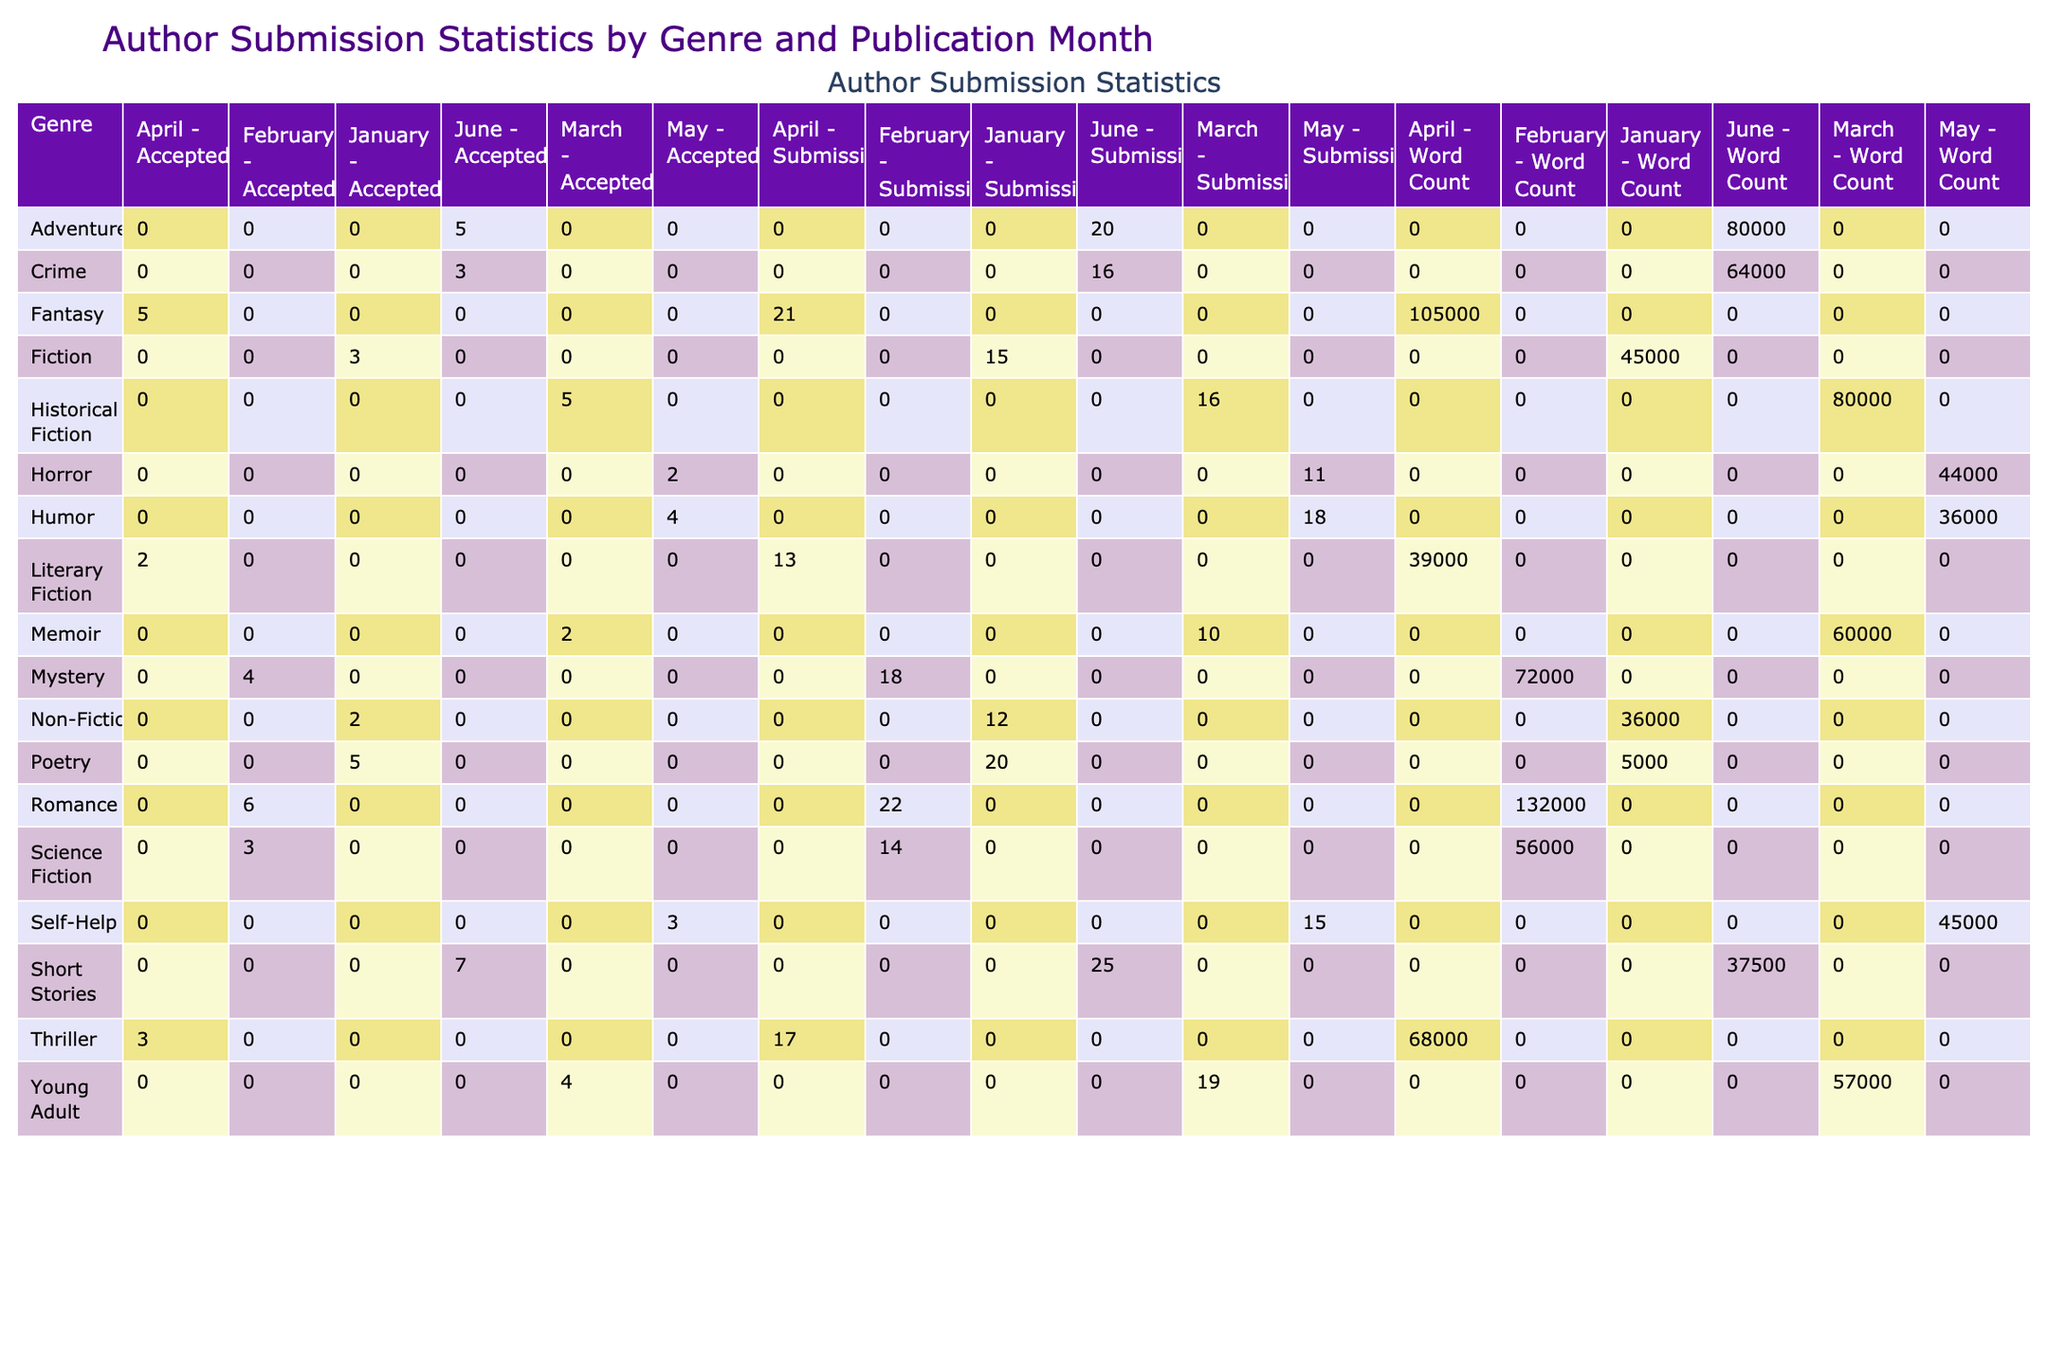What genre had the most submissions in February? In February, 'Romance' had 22 submissions, which is more than any other genre listed for that month.
Answer: Romance Which genre had the least accepted submissions overall? By looking at the 'Accepted' column across all genres, 'Horror' has the lowest count with 2 accepted submissions.
Answer: Horror What is the total number of submissions for Non-Fiction in January? The table indicates that Non-Fiction had a total of 12 submissions in January.
Answer: 12 Which genre had the highest total word count for submissions in April? In April, 'Fantasy' had a word count total of 105000, which is the highest among all genres in that month.
Answer: Fantasy Is the average acceptance rate for Poetry higher than that for Fiction? For Poetry, the acceptance rate is 25% (5 accepted out of 20 submissions), while for Fiction, it is 20% (3 accepted out of 15 submissions). Since 25% is greater than 20%, this statement is true.
Answer: Yes What was the total number of submissions across all genres for March? In March, the total submissions were 10 (Memoir) + 16 (Historical Fiction) + 19 (Young Adult) = 45 total submissions.
Answer: 45 How many total accepted submissions were there for all genres combined in June? In June, combining the accepted submissions we have: 3 (Crime) + 5 (Adventure) + 7 (Short Stories) = 15 accepted submissions total for June.
Answer: 15 Which genre had the highest number of submissions in May, and what was the number? The genre with the highest submissions in May is 'Humor' with a total of 18 submissions.
Answer: Humor, 18 What is the difference in total word count between Fiction and Mystery genres across all months? The total word count for Fiction is 45000 (January) + 0 + 0 + 0 = 45000. For Mystery, it is 0 + 0 + 0 + 72000 (February) = 72000. The difference is 72000 - 45000 = 27000.
Answer: 27000 